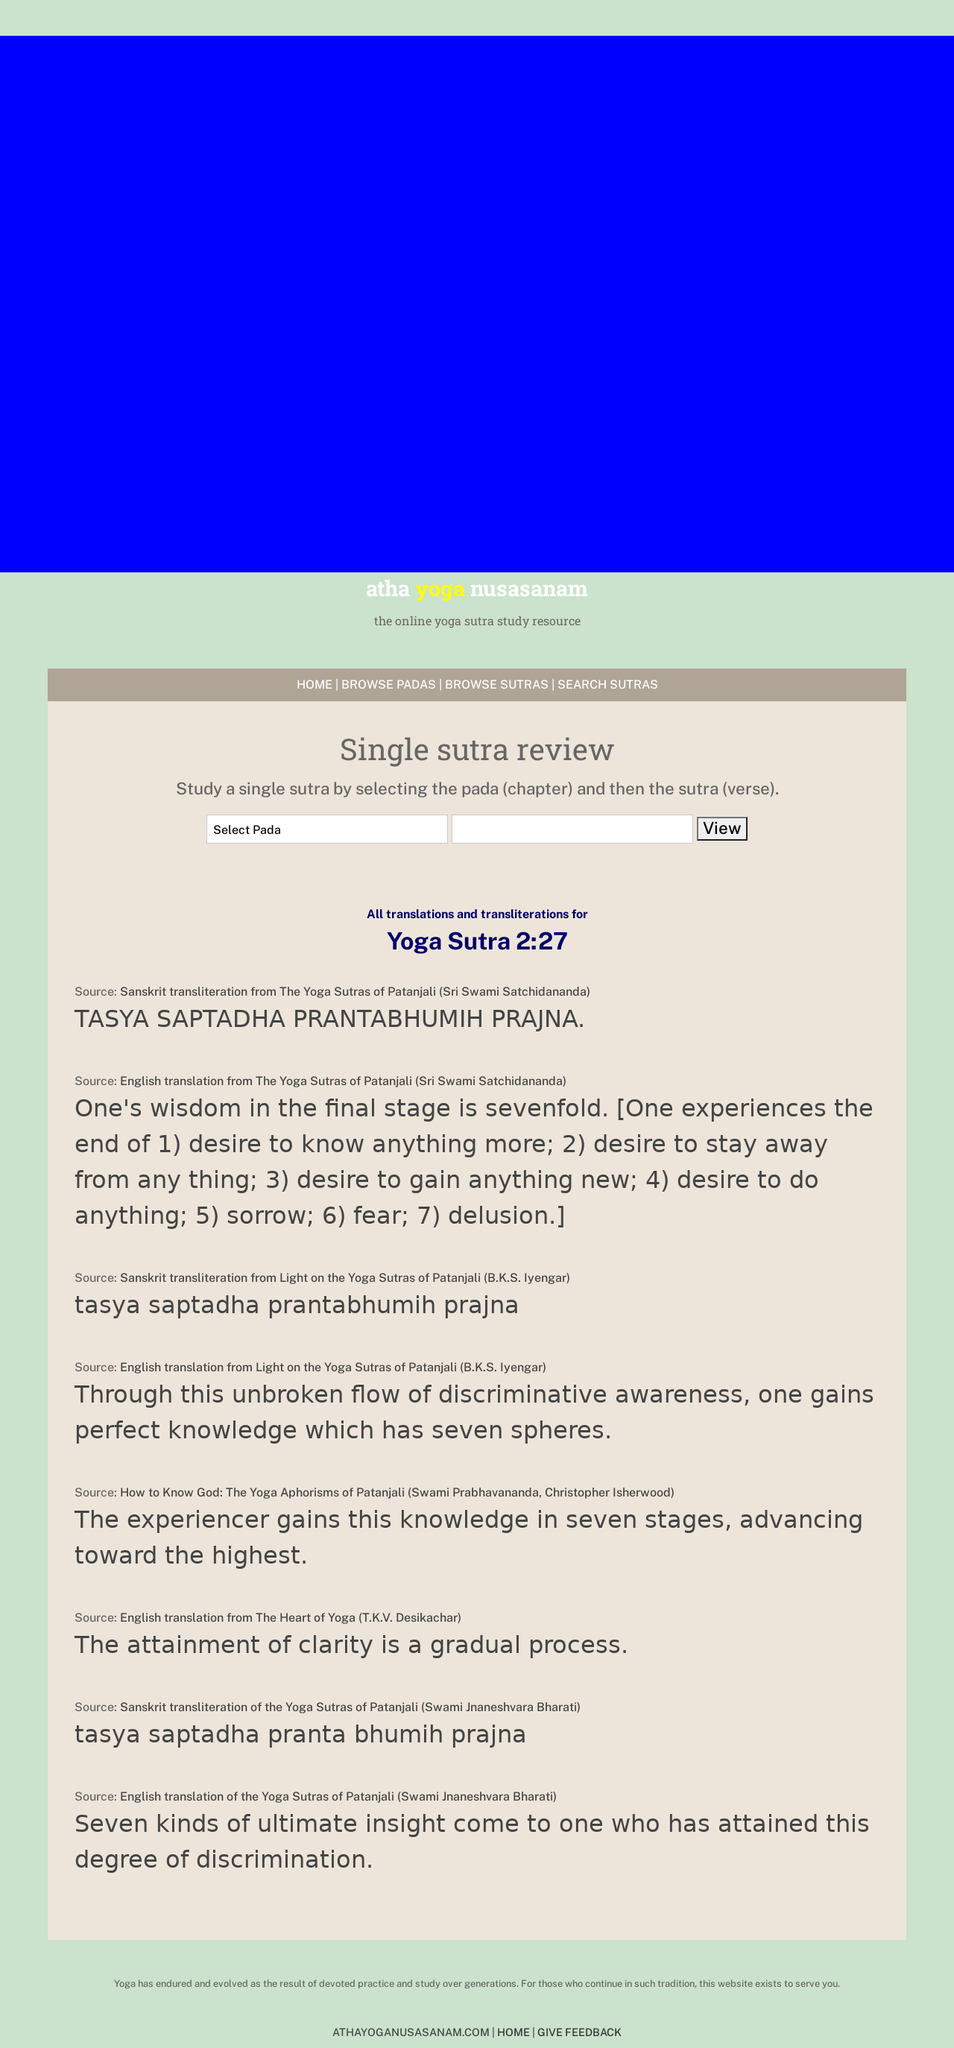What languages are used to build the yoga sutra study resource website shown in the image? The website for studying Yoga Sutras as represented in the image utilizes HTML for structuring the web pages, CSS for styling, and likely JavaScript for any interactive components such as navigational menus or handling form submissions. 